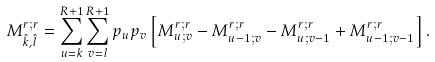<formula> <loc_0><loc_0><loc_500><loc_500>M _ { \hat { k } , \hat { l } } ^ { r ; r } = \sum _ { u = k } ^ { R + 1 } \sum _ { v = l } ^ { R + 1 } p _ { u } p _ { v } \left [ M _ { u ; v } ^ { r ; r } - M _ { u - 1 ; v } ^ { r ; r } - M _ { u ; v - 1 } ^ { r ; r } + M _ { u - 1 ; v - 1 } ^ { r ; r } \right ] .</formula> 